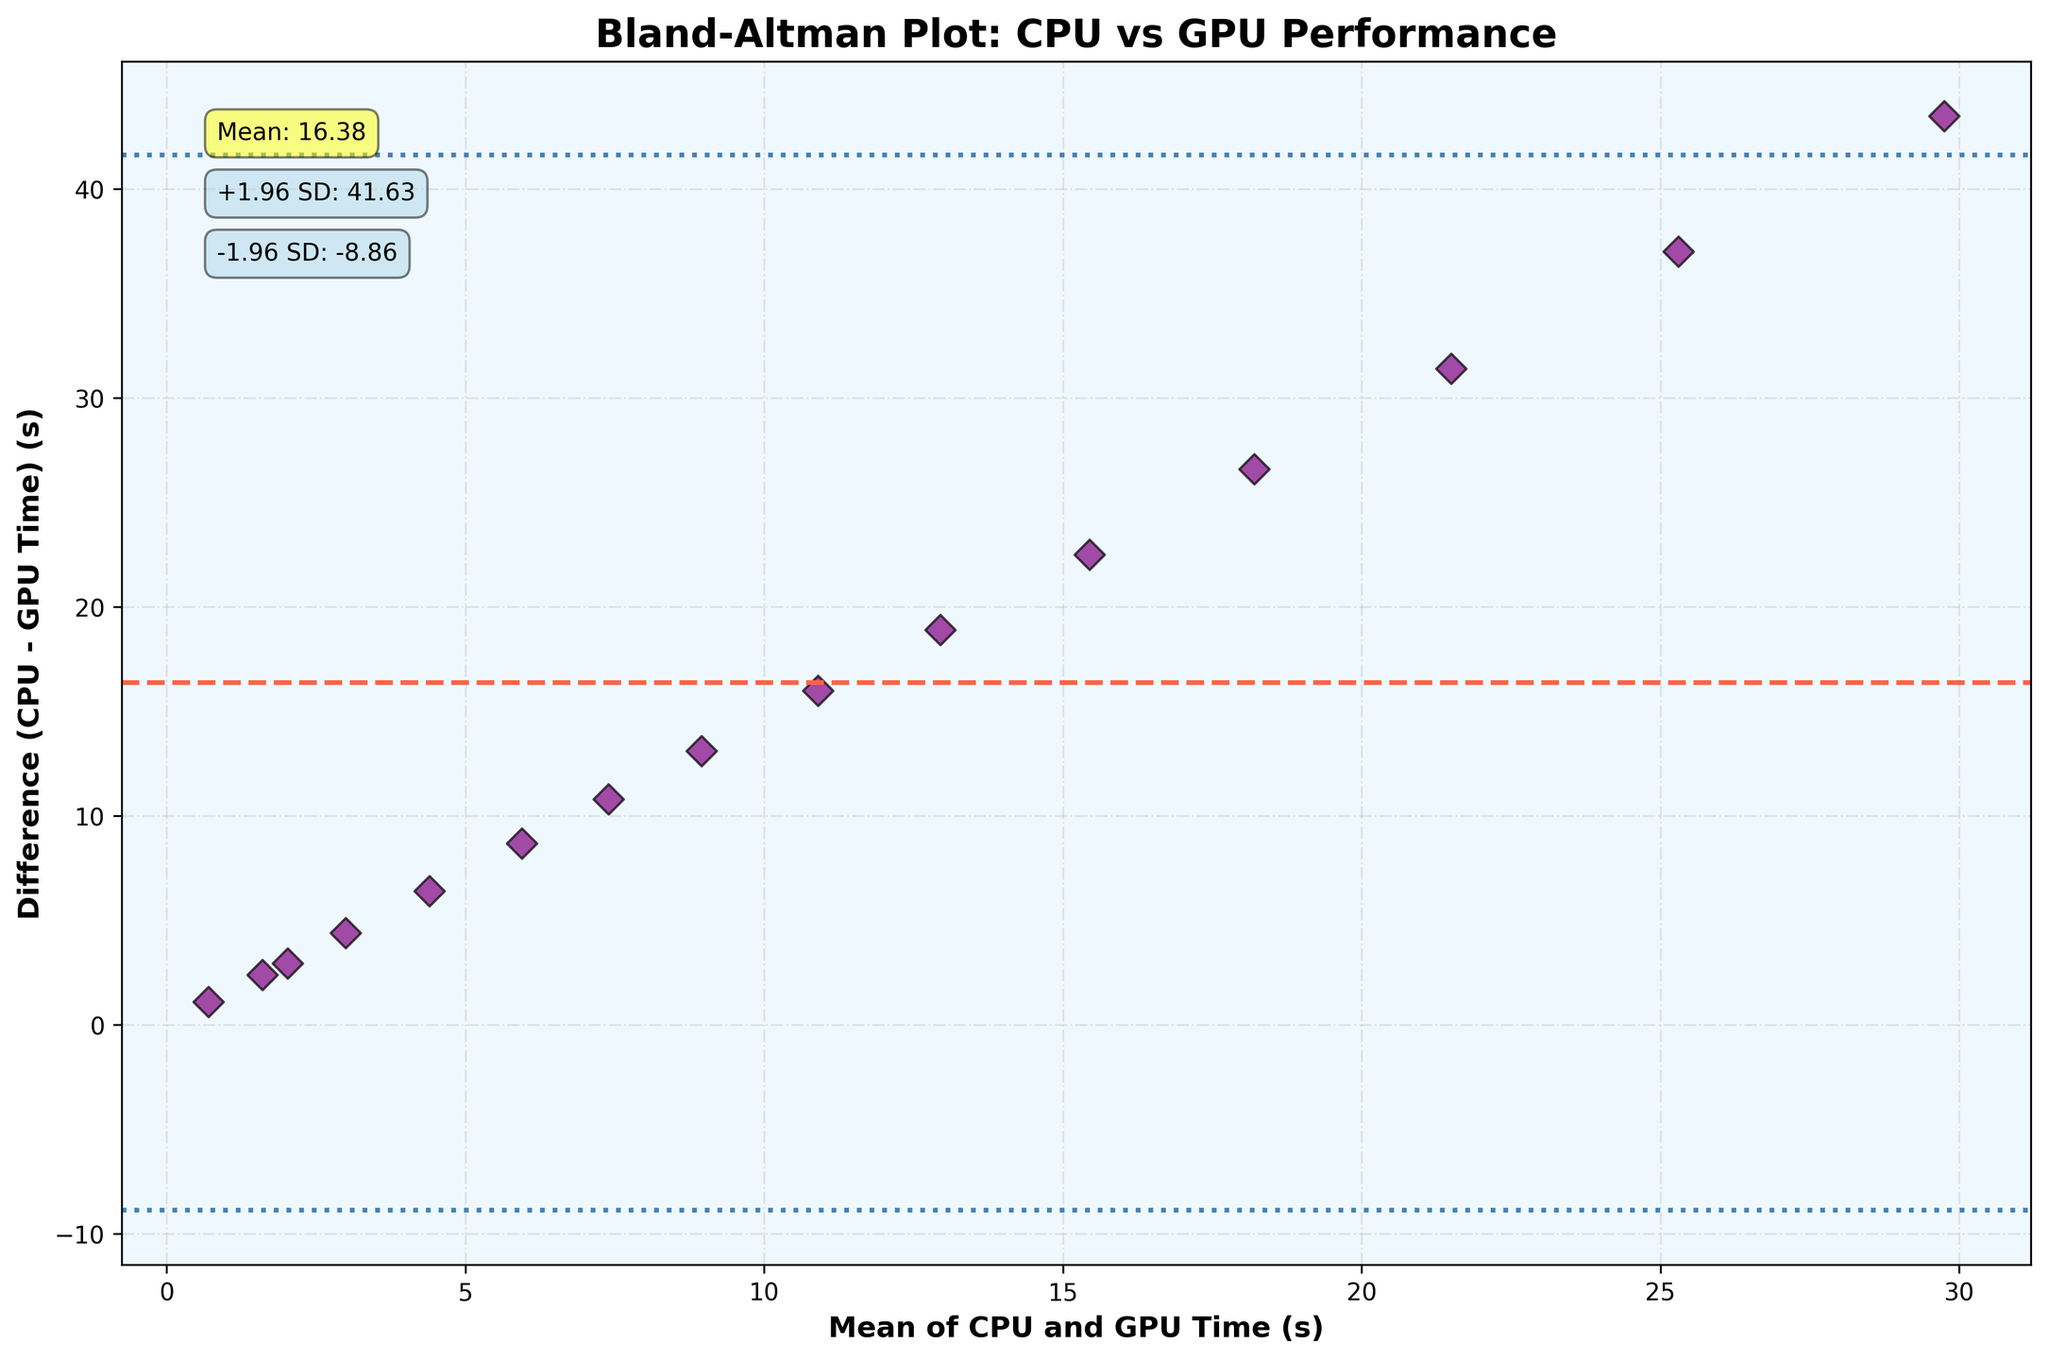How many data points are presented in the plot? To determine the number of data points, count the number of dots (scatter points) on the plot. Each dot represents a data point.
Answer: 15 What is the title of the plot? The title of the plot is typically located at the top. In this case, it states "Bland-Altman Plot: CPU vs GPU Performance."
Answer: Bland-Altman Plot: CPU vs GPU Performance What do the horizontal dashed and dotted lines represent? The horizontal dashed line represents the mean difference between CPU and GPU times, while the dotted lines represent the limits of agreement (mean ± 1.96 standard deviations)
Answer: Mean difference and Limits of Agreement (±1.96 SD) What is the mean difference between the CPU and GPU times, and where is it annotated on the plot? Look for the horizontal dashed line and the corresponding annotation box. The mean difference is explicitly mentioned in the annotation.
Answer: 10.71 How can you determine if there are any outliers in the data based on this plot? Check for data points that lie outside the dotted lines (limits of agreement). These points are considered outliers in a Bland-Altman plot.
Answer: Points outside the limits of agreement What are the values of the limits of agreement (upper and lower), and where are they annotated? Look for the dotted lines and the corresponding annotation boxes. These are explicitly mentioned in the plot.
Answer: +1.96 SD: 21.11, -1.96 SD: 0.30 Is there a visible trend in the differences between the CPU and GPU times? Observe the scatter points and their distribution. If the differences consistently increase or decrease with the mean values, there is a trend.
Answer: Yes, differences increase with the mean Which data points (if any) fall outside the limits of agreement? Analyze the scatter points to see which ones lie outside the upper and lower dotted lines (limits of agreement).
Answer: None What does the background color of the plot signify? The background color is used for better visual contrast and does not signify any specific data. In this case, it is light blue.
Answer: Light blue for contrast What is the range of the y-axis, and what does it signify? Check the y-axis from its minimum to maximum value. It signifies the differences in CPU and GPU times (CPU Time - GPU Time).
Answer: 0 to 30 